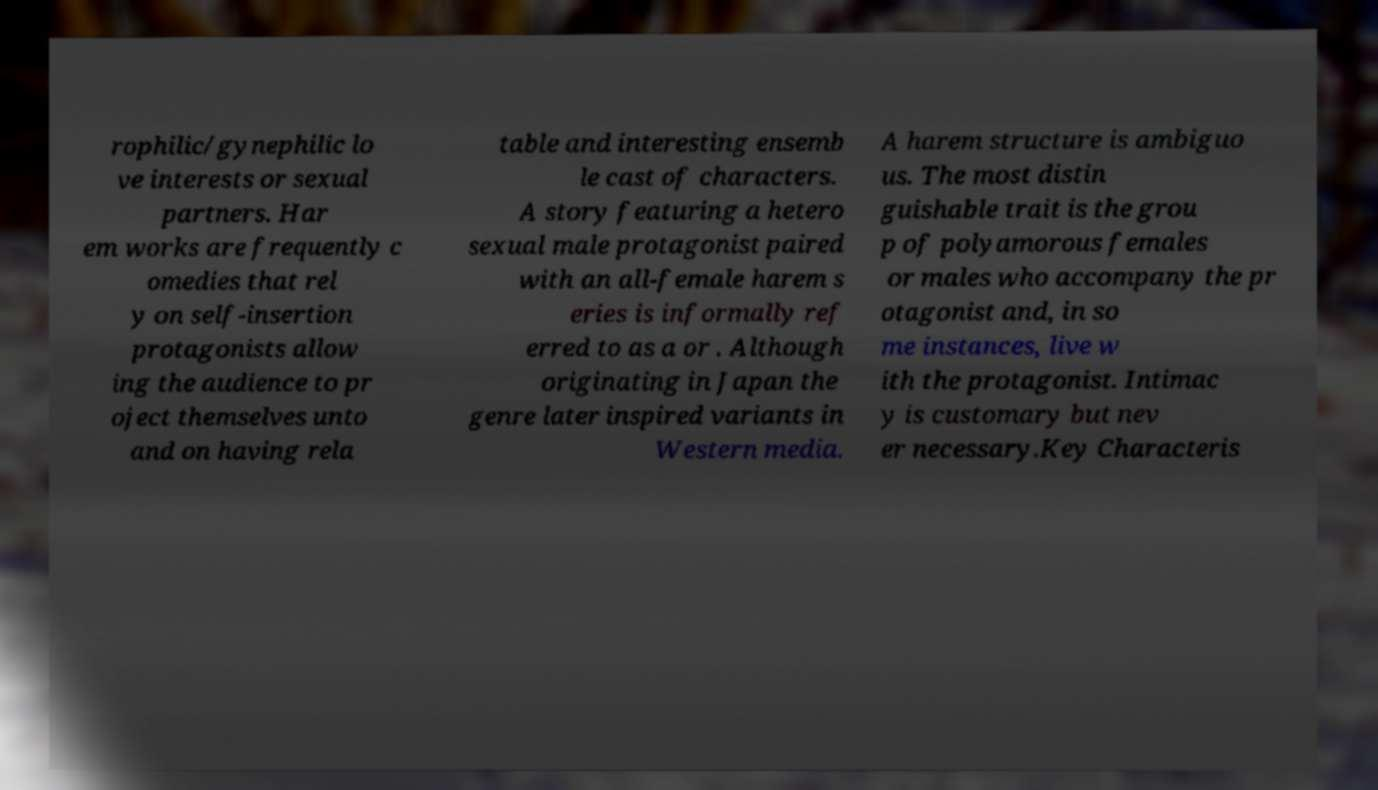Could you assist in decoding the text presented in this image and type it out clearly? rophilic/gynephilic lo ve interests or sexual partners. Har em works are frequently c omedies that rel y on self-insertion protagonists allow ing the audience to pr oject themselves unto and on having rela table and interesting ensemb le cast of characters. A story featuring a hetero sexual male protagonist paired with an all-female harem s eries is informally ref erred to as a or . Although originating in Japan the genre later inspired variants in Western media. A harem structure is ambiguo us. The most distin guishable trait is the grou p of polyamorous females or males who accompany the pr otagonist and, in so me instances, live w ith the protagonist. Intimac y is customary but nev er necessary.Key Characteris 